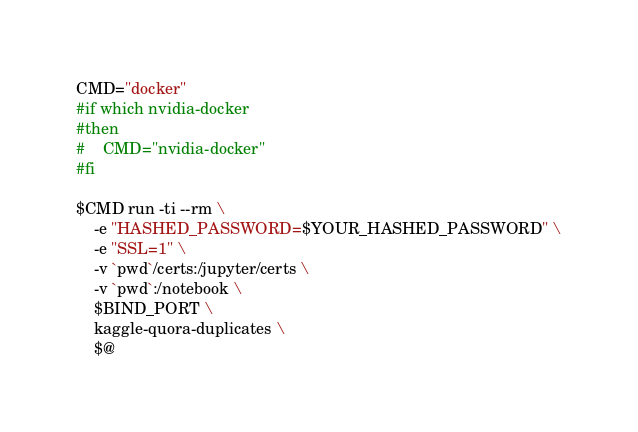Convert code to text. <code><loc_0><loc_0><loc_500><loc_500><_Bash_>CMD="docker"
#if which nvidia-docker
#then
#    CMD="nvidia-docker"
#fi

$CMD run -ti --rm \
    -e "HASHED_PASSWORD=$YOUR_HASHED_PASSWORD" \
    -e "SSL=1" \
    -v `pwd`/certs:/jupyter/certs \
    -v `pwd`:/notebook \
    $BIND_PORT \
    kaggle-quora-duplicates \
    $@
</code> 